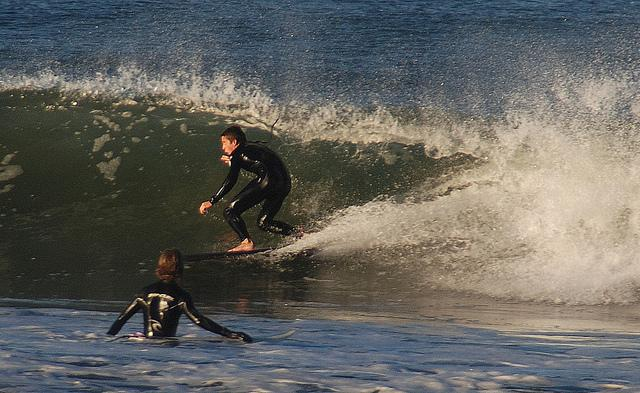Why is the man in black crouched?

Choices:
A) to dive
B) to jump
C) gain speed
D) to sit gain speed 